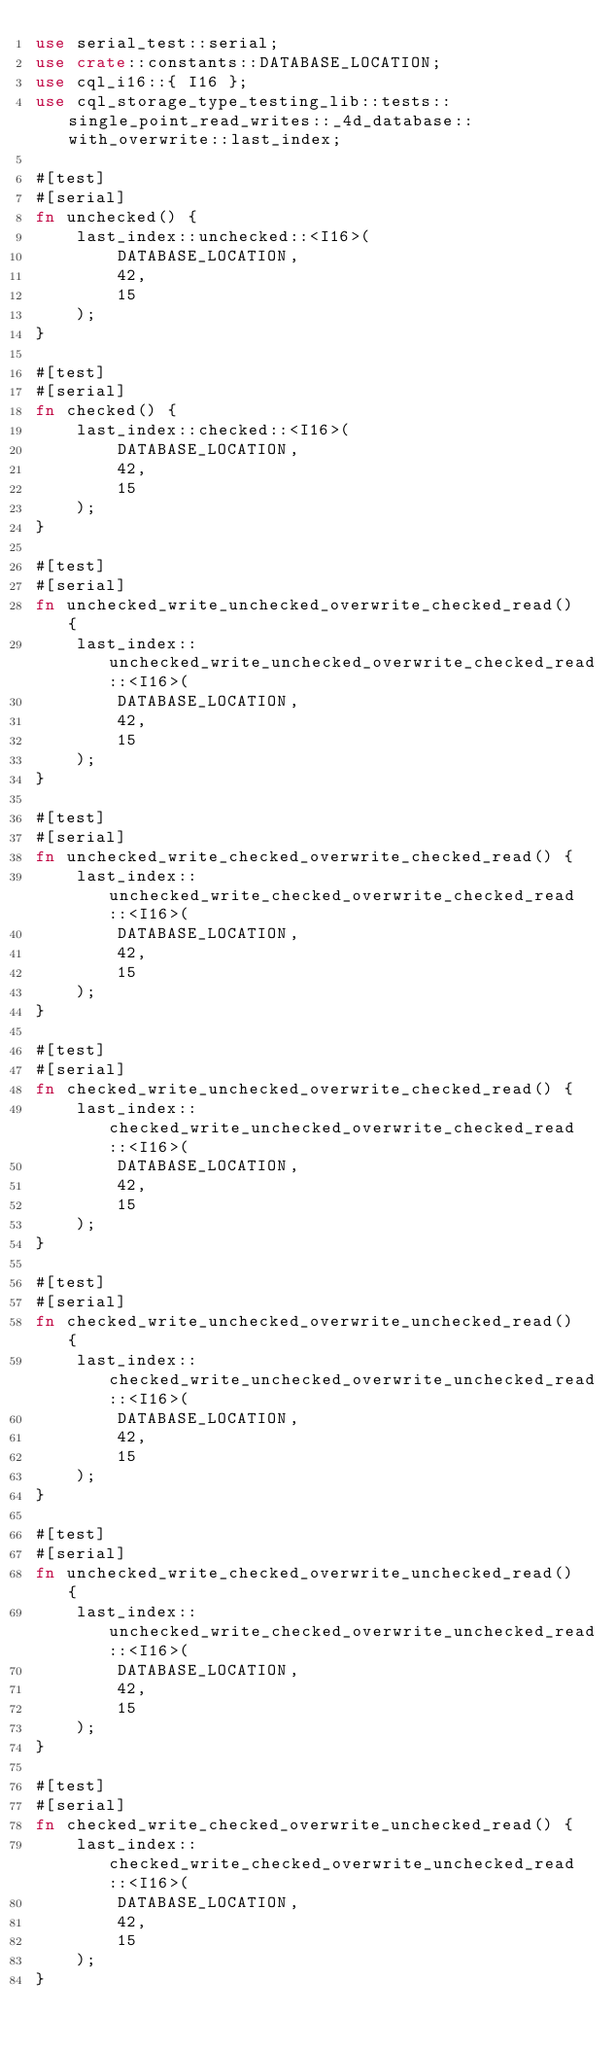Convert code to text. <code><loc_0><loc_0><loc_500><loc_500><_Rust_>use serial_test::serial;
use crate::constants::DATABASE_LOCATION;
use cql_i16::{ I16 };
use cql_storage_type_testing_lib::tests::single_point_read_writes::_4d_database::with_overwrite::last_index;

#[test]
#[serial]
fn unchecked() {
    last_index::unchecked::<I16>(
        DATABASE_LOCATION,
        42,
        15
    );
}

#[test]
#[serial]
fn checked() {
    last_index::checked::<I16>(
        DATABASE_LOCATION,
        42,
        15
    );
}

#[test]
#[serial]
fn unchecked_write_unchecked_overwrite_checked_read() {
    last_index::unchecked_write_unchecked_overwrite_checked_read::<I16>(
        DATABASE_LOCATION,
        42,
        15
    );
}

#[test]
#[serial]
fn unchecked_write_checked_overwrite_checked_read() {
    last_index::unchecked_write_checked_overwrite_checked_read::<I16>(
        DATABASE_LOCATION,
        42,
        15
    );
}

#[test]
#[serial]
fn checked_write_unchecked_overwrite_checked_read() {
    last_index::checked_write_unchecked_overwrite_checked_read::<I16>(
        DATABASE_LOCATION,
        42,
        15
    );
}

#[test]
#[serial]
fn checked_write_unchecked_overwrite_unchecked_read() {
    last_index::checked_write_unchecked_overwrite_unchecked_read::<I16>(
        DATABASE_LOCATION,
        42,
        15
    );
}

#[test]
#[serial]
fn unchecked_write_checked_overwrite_unchecked_read() {
    last_index::unchecked_write_checked_overwrite_unchecked_read::<I16>(
        DATABASE_LOCATION,
        42,
        15
    );
}

#[test]
#[serial]
fn checked_write_checked_overwrite_unchecked_read() {
    last_index::checked_write_checked_overwrite_unchecked_read::<I16>(
        DATABASE_LOCATION,
        42,
        15
    );
}
</code> 